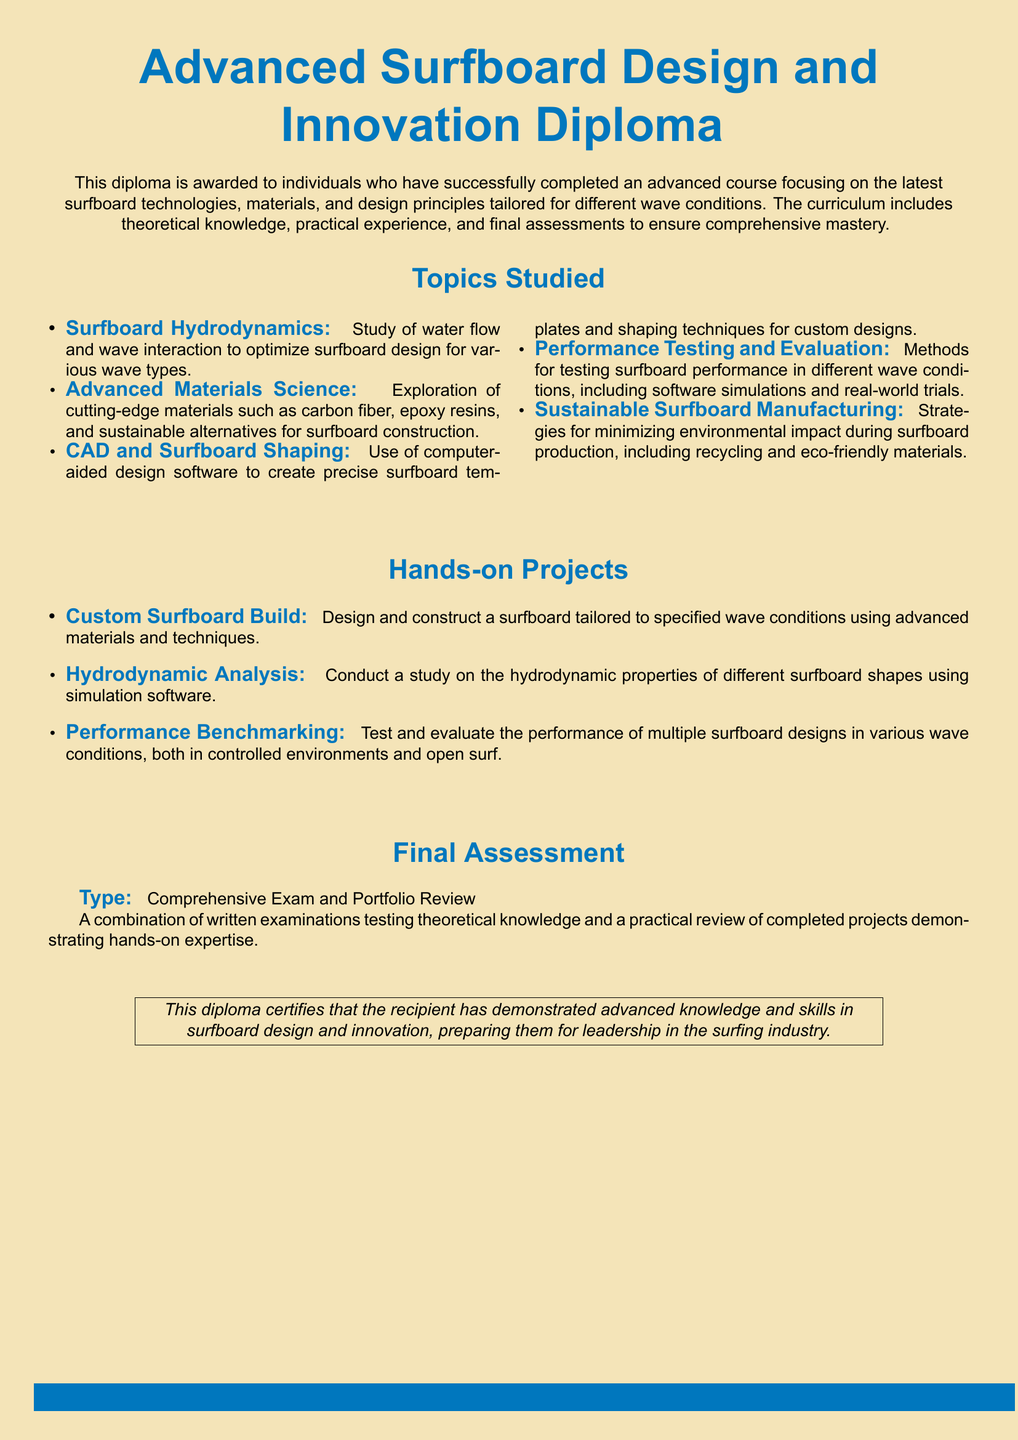What is the name of the diploma? The name of the diploma is stated at the top of the document.
Answer: Advanced Surfboard Design and Innovation Diploma Who is the diploma awarded to? The document specifies the recipients of the diploma.
Answer: Individuals who have successfully completed an advanced course What is one topic studied in the diploma? The document lists several topics studied in the curriculum.
Answer: Surfboard Hydrodynamics What is the type of final assessment? The document describes the type of final assessment for the diploma.
Answer: Comprehensive Exam and Portfolio Review What is one hands-on project included in the curriculum? The document includes a list of hands-on projects that participants complete.
Answer: Custom Surfboard Build What materials are emphasized in the Advanced Materials Science topic? The document mentions materials studied in this section.
Answer: Carbon fiber, epoxy resins, and sustainable alternatives What does the diploma certify the recipient has demonstrated? The final statement in the document describes the achievements of the diploma recipients.
Answer: Advanced knowledge and skills in surfboard design and innovation What does the hydrodynamic analysis project study? The document explains what the hydrodynamic analysis project involves.
Answer: Hydrodynamic properties of different surfboard shapes What is a strategy mentioned for sustainable surfboard manufacturing? The document outlines methods for reducing environmental impact in surfboard production.
Answer: Recycling and eco-friendly materials 